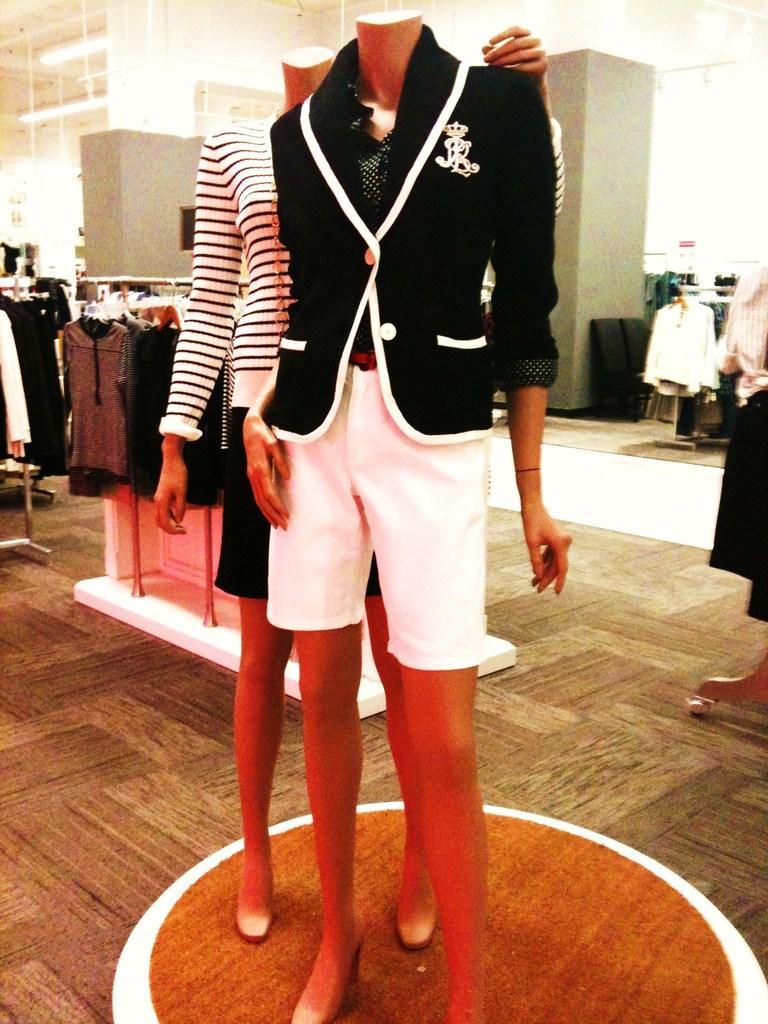Could you give a brief overview of what you see in this image? In this picture I can see there are two statues and they are wearing clothes, there are many other clothes on to left and right. There are lights attached to the ceiling. 